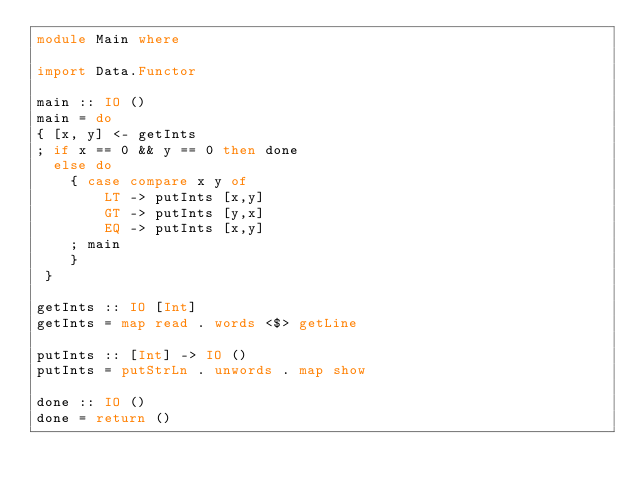<code> <loc_0><loc_0><loc_500><loc_500><_Haskell_>module Main where

import Data.Functor

main :: IO ()
main = do
{ [x, y] <- getInts
; if x == 0 && y == 0 then done
  else do
    { case compare x y of
        LT -> putInts [x,y]
        GT -> putInts [y,x]
        EQ -> putInts [x,y]
    ; main
    }
 }

getInts :: IO [Int]
getInts = map read . words <$> getLine

putInts :: [Int] -> IO ()
putInts = putStrLn . unwords . map show

done :: IO ()
done = return ()</code> 